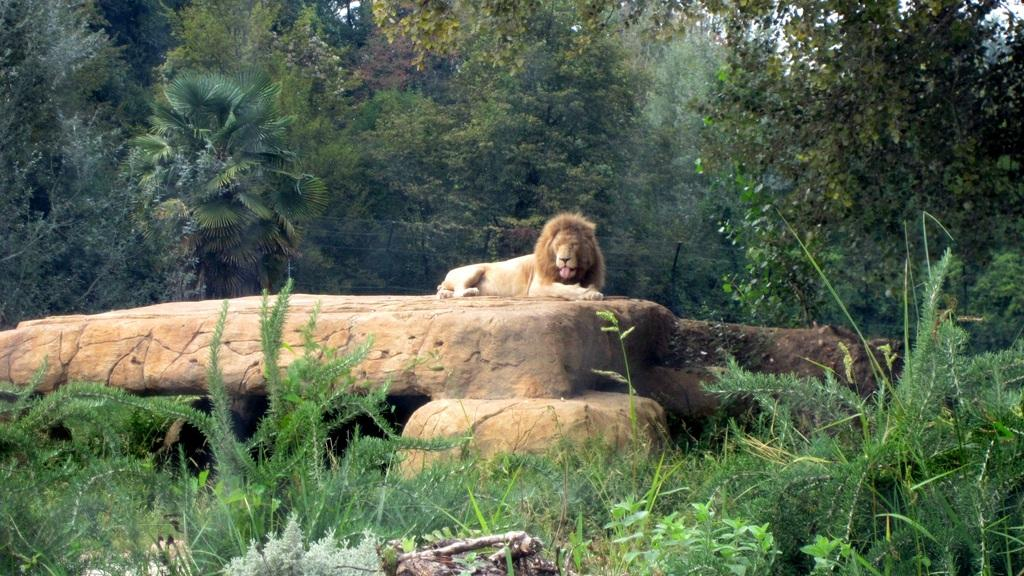What animal is sitting on a rock in the image? There is a lion sitting on a rock in the image. What can be seen on the ground at the bottom of the image? There are plants on the land at the bottom of the image. What is behind the rock in the image? There is a fence behind the rock in the image. What type of vegetation is visible in the background of the image? There are trees in the background of the image. What type of treatment is the lion receiving in the image? There is no indication in the image that the lion is receiving any treatment; it is simply sitting on a rock. 